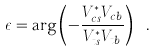<formula> <loc_0><loc_0><loc_500><loc_500>\epsilon = \arg \left ( - \frac { V _ { c s } ^ { \ast } V _ { c b } } { V _ { t s } ^ { \ast } V _ { t b } } \right ) \ .</formula> 